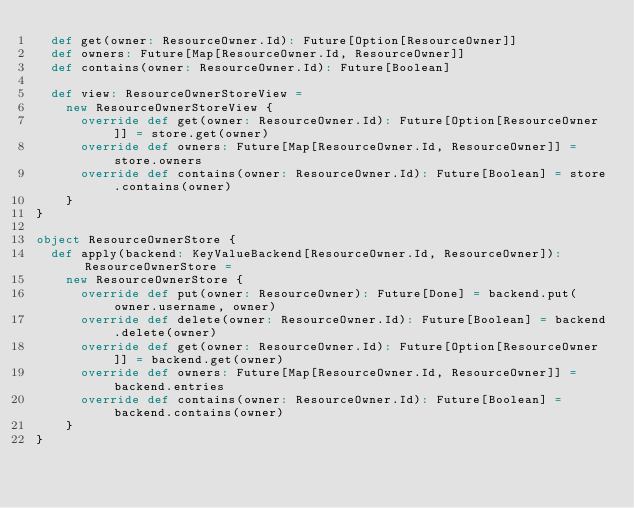Convert code to text. <code><loc_0><loc_0><loc_500><loc_500><_Scala_>  def get(owner: ResourceOwner.Id): Future[Option[ResourceOwner]]
  def owners: Future[Map[ResourceOwner.Id, ResourceOwner]]
  def contains(owner: ResourceOwner.Id): Future[Boolean]

  def view: ResourceOwnerStoreView =
    new ResourceOwnerStoreView {
      override def get(owner: ResourceOwner.Id): Future[Option[ResourceOwner]] = store.get(owner)
      override def owners: Future[Map[ResourceOwner.Id, ResourceOwner]] = store.owners
      override def contains(owner: ResourceOwner.Id): Future[Boolean] = store.contains(owner)
    }
}

object ResourceOwnerStore {
  def apply(backend: KeyValueBackend[ResourceOwner.Id, ResourceOwner]): ResourceOwnerStore =
    new ResourceOwnerStore {
      override def put(owner: ResourceOwner): Future[Done] = backend.put(owner.username, owner)
      override def delete(owner: ResourceOwner.Id): Future[Boolean] = backend.delete(owner)
      override def get(owner: ResourceOwner.Id): Future[Option[ResourceOwner]] = backend.get(owner)
      override def owners: Future[Map[ResourceOwner.Id, ResourceOwner]] = backend.entries
      override def contains(owner: ResourceOwner.Id): Future[Boolean] = backend.contains(owner)
    }
}
</code> 